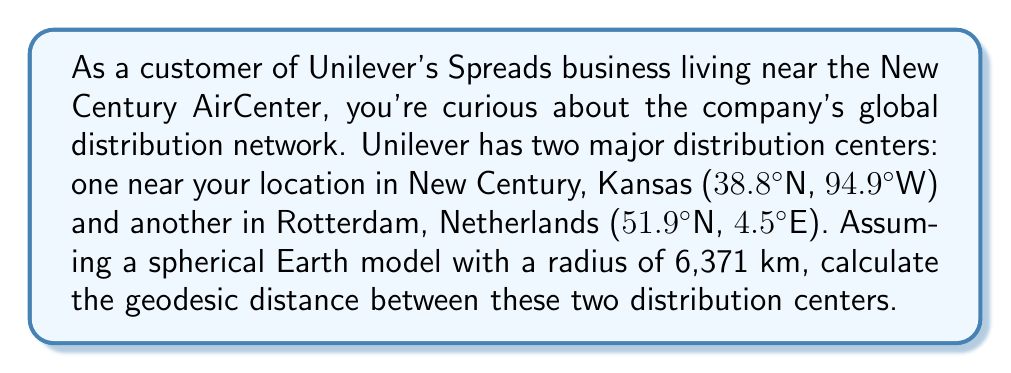Solve this math problem. To solve this problem, we'll use the Haversine formula, which calculates the great-circle distance between two points on a sphere given their latitudes and longitudes. The formula is:

$$d = 2R \arcsin\left(\sqrt{\sin^2\left(\frac{\phi_2 - \phi_1}{2}\right) + \cos(\phi_1)\cos(\phi_2)\sin^2\left(\frac{\lambda_2 - \lambda_1}{2}\right)}\right)$$

Where:
- $d$ is the distance between the two points along the sphere's surface
- $R$ is the radius of the sphere (Earth in this case)
- $\phi_1, \phi_2$ are the latitudes of point 1 and point 2 in radians
- $\lambda_1, \lambda_2$ are the longitudes of point 1 and point 2 in radians

Let's break down the solution step-by-step:

1. Convert the latitudes and longitudes from degrees to radians:
   $\phi_1 = 38.8° \times \frac{\pi}{180} = 0.6772$ rad
   $\lambda_1 = -94.9° \times \frac{\pi}{180} = -1.6563$ rad
   $\phi_2 = 51.9° \times \frac{\pi}{180} = 0.9060$ rad
   $\lambda_2 = 4.5° \times \frac{\pi}{180} = 0.0785$ rad

2. Calculate the differences:
   $\Delta\phi = \phi_2 - \phi_1 = 0.9060 - 0.6772 = 0.2288$ rad
   $\Delta\lambda = \lambda_2 - \lambda_1 = 0.0785 - (-1.6563) = 1.7348$ rad

3. Apply the Haversine formula:
   $$d = 2 \times 6371 \times \arcsin\left(\sqrt{\sin^2\left(\frac{0.2288}{2}\right) + \cos(0.6772)\cos(0.9060)\sin^2\left(\frac{1.7348}{2}\right)}\right)$$

4. Solve the equation:
   $$d = 12742 \times \arcsin\left(\sqrt{0.0013 + 0.7521 \times 0.6051}\right)$$
   $$d = 12742 \times \arcsin\left(\sqrt{0.4562}\right)$$
   $$d = 12742 \times \arcsin(0.6754)$$
   $$d = 12742 \times 0.7396$$
   $$d = 9424.18$$ km

Therefore, the geodesic distance between the two Unilever distribution centers is approximately 9,424 km.
Answer: The geodesic distance between Unilever's distribution centers in New Century, Kansas and Rotterdam, Netherlands is approximately 9,424 km. 